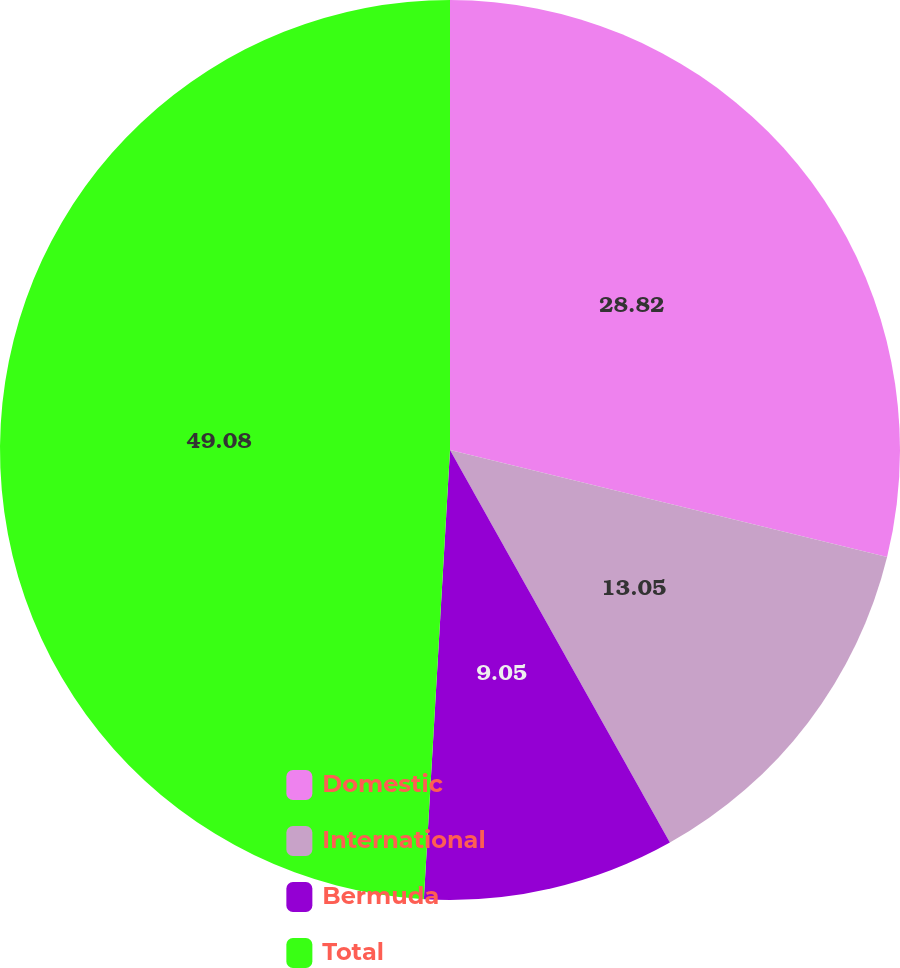<chart> <loc_0><loc_0><loc_500><loc_500><pie_chart><fcel>Domestic<fcel>International<fcel>Bermuda<fcel>Total<nl><fcel>28.82%<fcel>13.05%<fcel>9.05%<fcel>49.07%<nl></chart> 